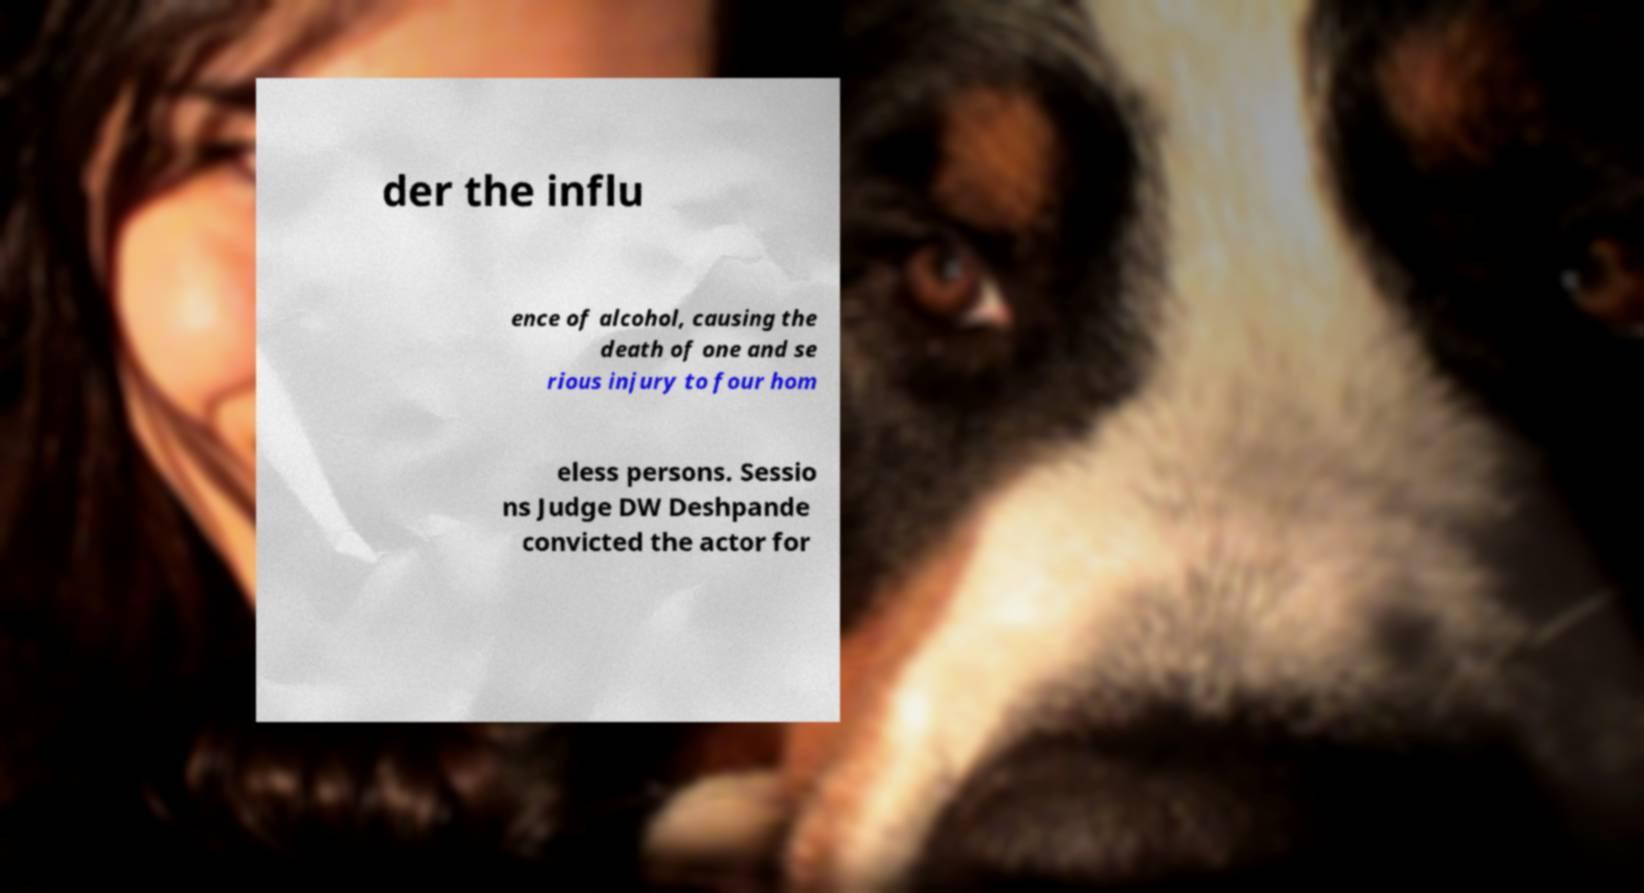Please identify and transcribe the text found in this image. der the influ ence of alcohol, causing the death of one and se rious injury to four hom eless persons. Sessio ns Judge DW Deshpande convicted the actor for 